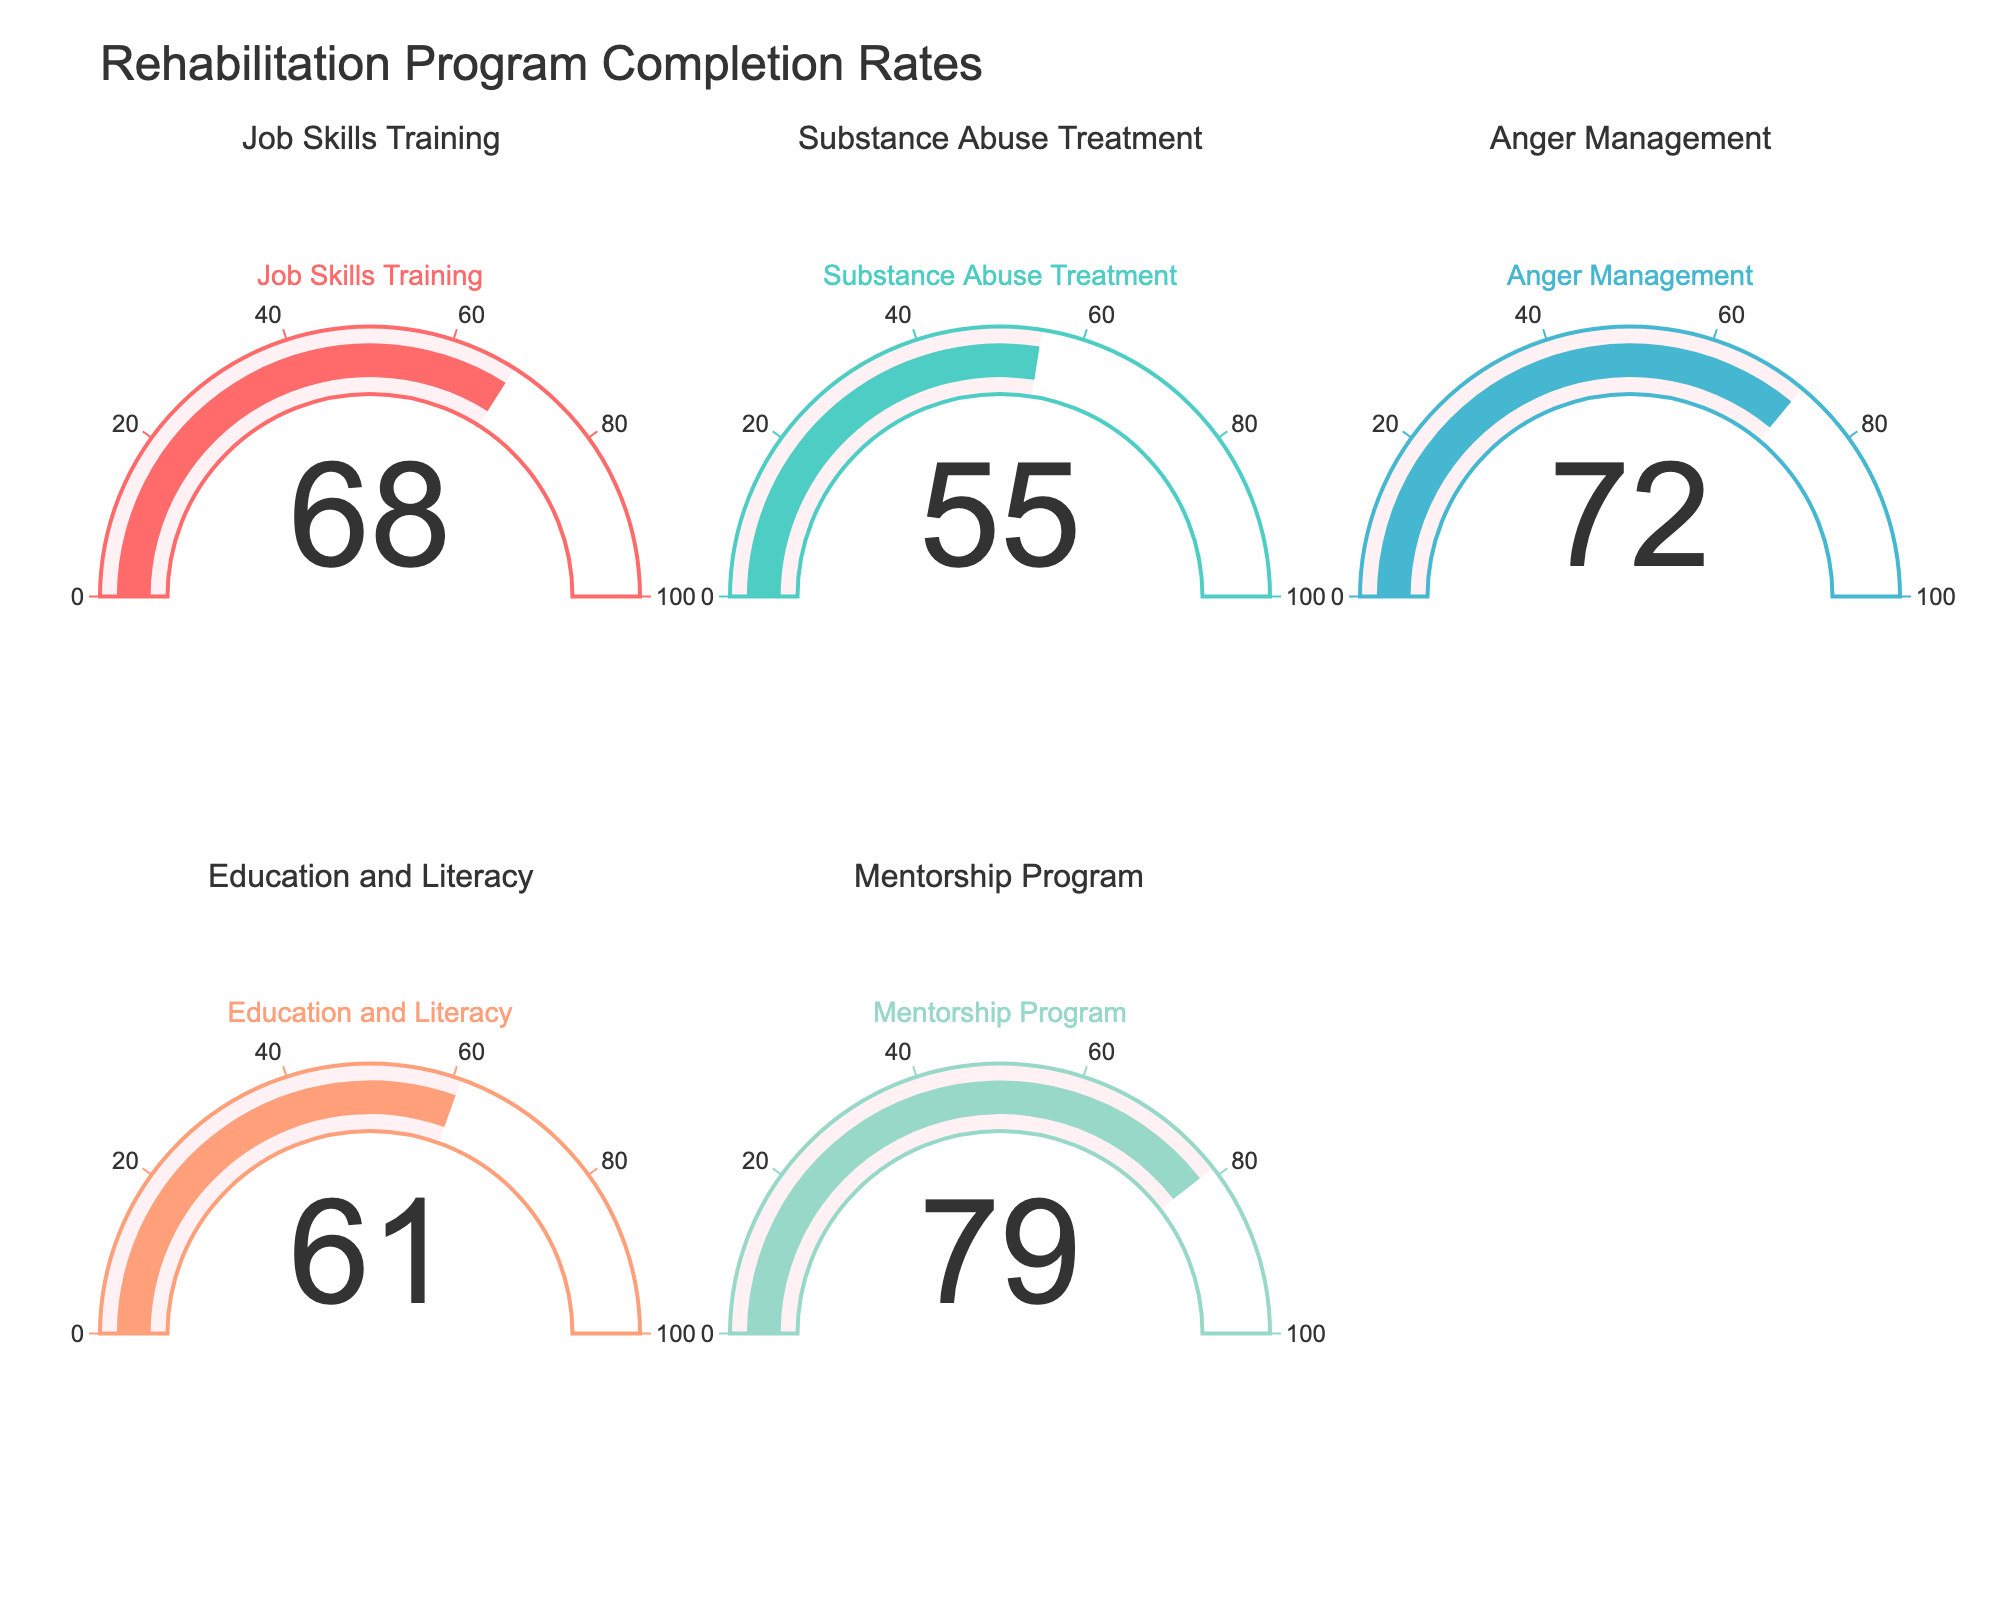Which rehabilitation program has the highest completion rate? The gauge for the Mentorship Program shows the highest value at 79%.
Answer: Mentorship Program What is the completion rate for the Job Skills Training program? The gauge for Job Skills Training shows a value of 68%.
Answer: 68% Which program has a lower completion rate, Substance Abuse Treatment or Anger Management? The Substance Abuse Treatment program has a completion rate of 55%, while the Anger Management program has a higher completion rate of 72%.
Answer: Substance Abuse Treatment How much higher is the completion rate of the Education and Literacy program compared to Substance Abuse Treatment? The completion rate for Education and Literacy is 61%, and for Substance Abuse Treatment, it is 55%. The difference is 61% - 55% = 6%.
Answer: 6% What is the average completion rate across all the programs? The completion rates are 68, 55, 72, 61, and 79. The sum is 335, and there are 5 programs. The average is 335 / 5 = 67%.
Answer: 67% Is the completion rate for Anger Management above or below the overall average completion rate? The completion rate for Anger Management is 72%, and the overall average is 67%. Since 72% > 67%, it is above the average.
Answer: Above Arrange the rehabilitation programs in descending order based on their completion rates. The completion rates in descending order are 79% (Mentorship Program), 72% (Anger Management), 68% (Job Skills Training), 61% (Education and Literacy), and 55% (Substance Abuse Treatment).
Answer: Mentorship Program, Anger Management, Job Skills Training, Education and Literacy, Substance Abuse Treatment What is the median completion rate of the programs? The completion rates are 55, 61, 68, 72, and 79. The median is the middle value when arranged in ascending order, which is 68.
Answer: 68 